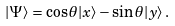<formula> <loc_0><loc_0><loc_500><loc_500>| \Psi \rangle = \cos \theta | x \rangle - \sin \theta | y \rangle \, .</formula> 